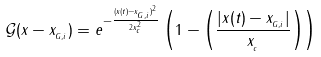<formula> <loc_0><loc_0><loc_500><loc_500>\mathcal { G } ( x - x _ { _ { G , i } } ) = e ^ { - \frac { ( x ( t ) - x _ { _ { G , i } } ) ^ { 2 } } { 2 x _ { _ { c } } ^ { 2 } } } \left ( 1 - \left ( \frac { | x ( t ) - x _ { _ { G , i } } | } { x _ { _ { c } } } \right ) \right )</formula> 